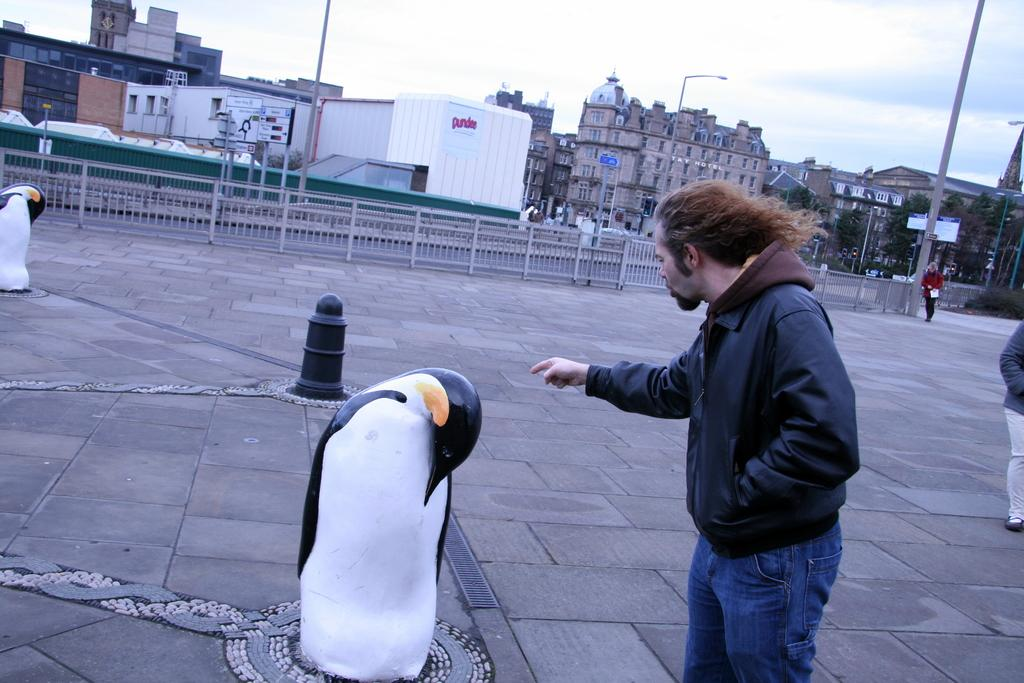Who or what can be seen in the image? There are people and sculptures in the image. What can be seen in the background of the image? There are buildings, poles, trees, and sky visible in the background of the image. What structures are present in the image? There is a fence and boards in the image. How many hands are visible in the image? There is no specific mention of hands in the image, so it is not possible to determine how many hands are visible. 